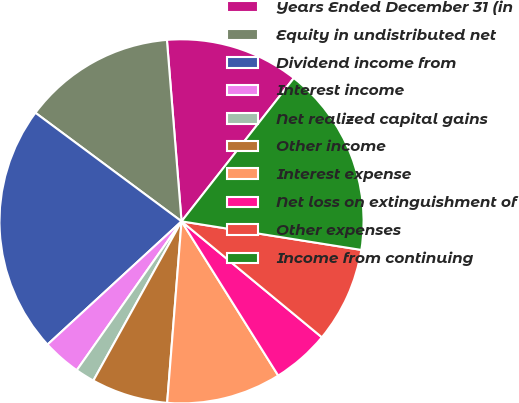<chart> <loc_0><loc_0><loc_500><loc_500><pie_chart><fcel>Years Ended December 31 (in<fcel>Equity in undistributed net<fcel>Dividend income from<fcel>Interest income<fcel>Net realized capital gains<fcel>Other income<fcel>Interest expense<fcel>Net loss on extinguishment of<fcel>Other expenses<fcel>Income from continuing<nl><fcel>11.86%<fcel>13.55%<fcel>22.0%<fcel>3.41%<fcel>1.71%<fcel>6.79%<fcel>10.17%<fcel>5.1%<fcel>8.48%<fcel>16.93%<nl></chart> 